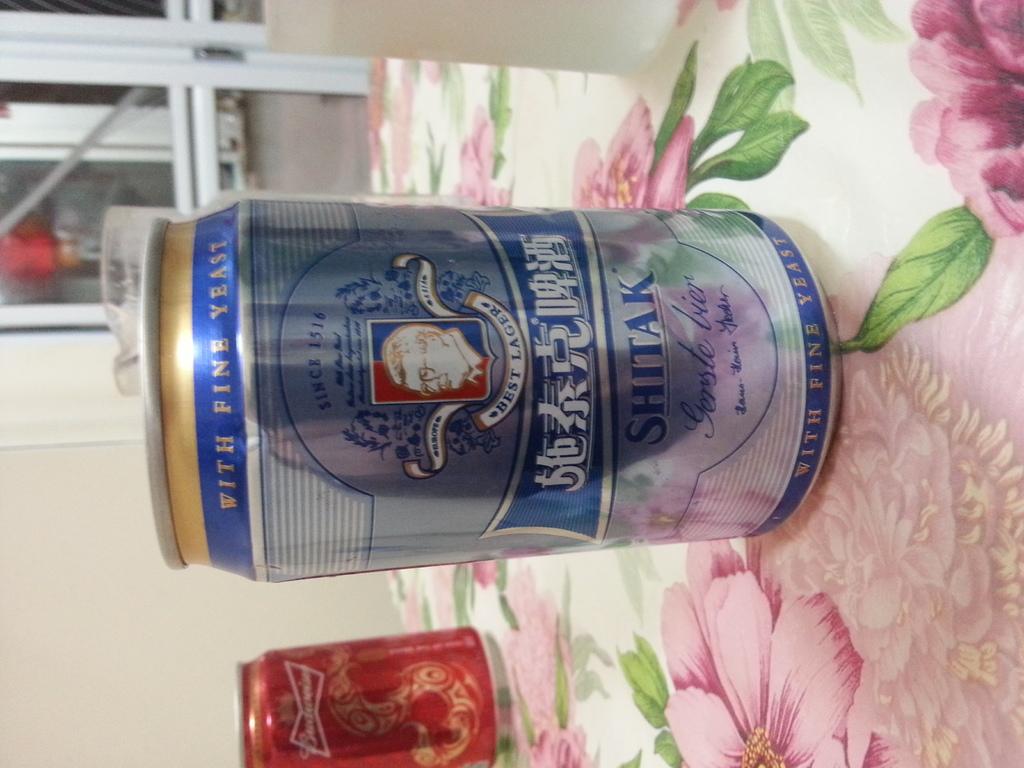What was a key ingredient in the fermentation process of this lager?
Offer a very short reply. Yeast. When was this brand established?
Keep it short and to the point. 1516. 